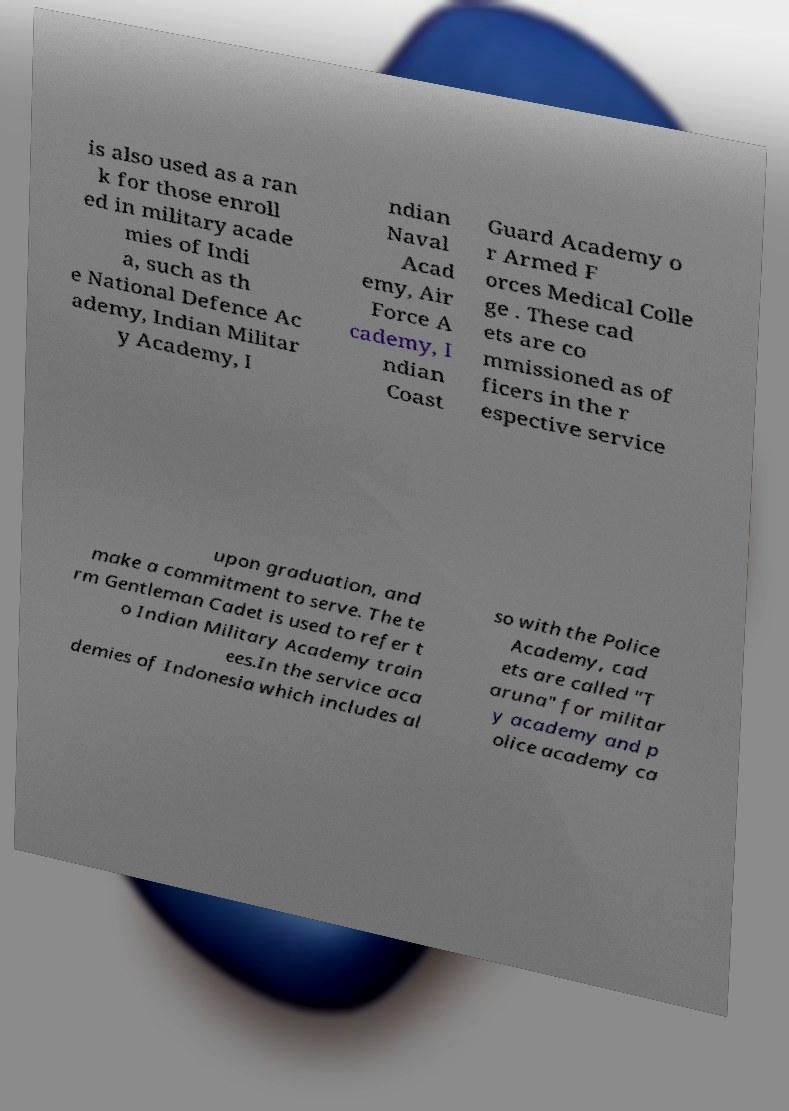Please identify and transcribe the text found in this image. is also used as a ran k for those enroll ed in military acade mies of Indi a, such as th e National Defence Ac ademy, Indian Militar y Academy, I ndian Naval Acad emy, Air Force A cademy, I ndian Coast Guard Academy o r Armed F orces Medical Colle ge . These cad ets are co mmissioned as of ficers in the r espective service upon graduation, and make a commitment to serve. The te rm Gentleman Cadet is used to refer t o Indian Military Academy train ees.In the service aca demies of Indonesia which includes al so with the Police Academy, cad ets are called "T aruna" for militar y academy and p olice academy ca 